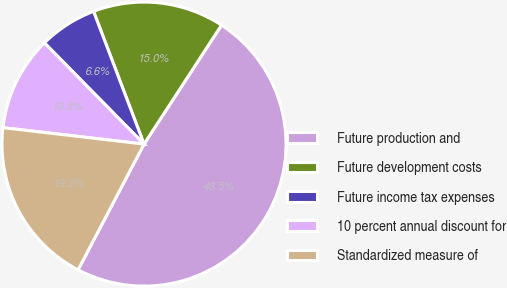Convert chart. <chart><loc_0><loc_0><loc_500><loc_500><pie_chart><fcel>Future production and<fcel>Future development costs<fcel>Future income tax expenses<fcel>10 percent annual discount for<fcel>Standardized measure of<nl><fcel>48.5%<fcel>14.97%<fcel>6.59%<fcel>10.78%<fcel>19.16%<nl></chart> 